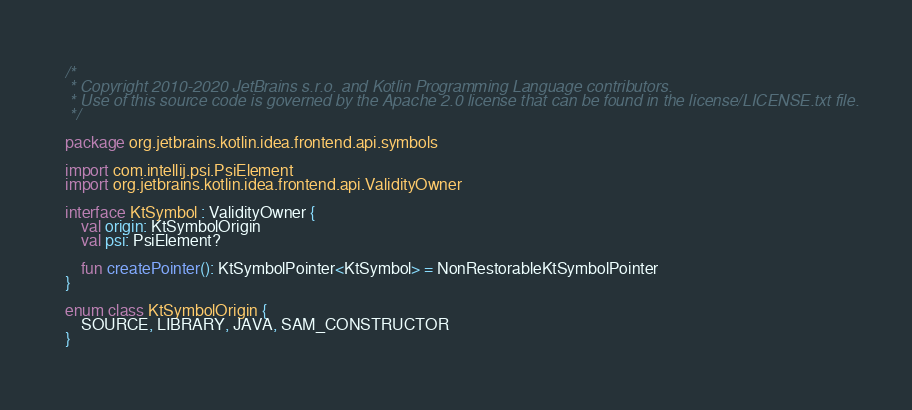<code> <loc_0><loc_0><loc_500><loc_500><_Kotlin_>/*
 * Copyright 2010-2020 JetBrains s.r.o. and Kotlin Programming Language contributors.
 * Use of this source code is governed by the Apache 2.0 license that can be found in the license/LICENSE.txt file.
 */

package org.jetbrains.kotlin.idea.frontend.api.symbols

import com.intellij.psi.PsiElement
import org.jetbrains.kotlin.idea.frontend.api.ValidityOwner

interface KtSymbol : ValidityOwner {
    val origin: KtSymbolOrigin
    val psi: PsiElement?

    fun createPointer(): KtSymbolPointer<KtSymbol> = NonRestorableKtSymbolPointer
}

enum class KtSymbolOrigin {
    SOURCE, LIBRARY, JAVA, SAM_CONSTRUCTOR
}</code> 